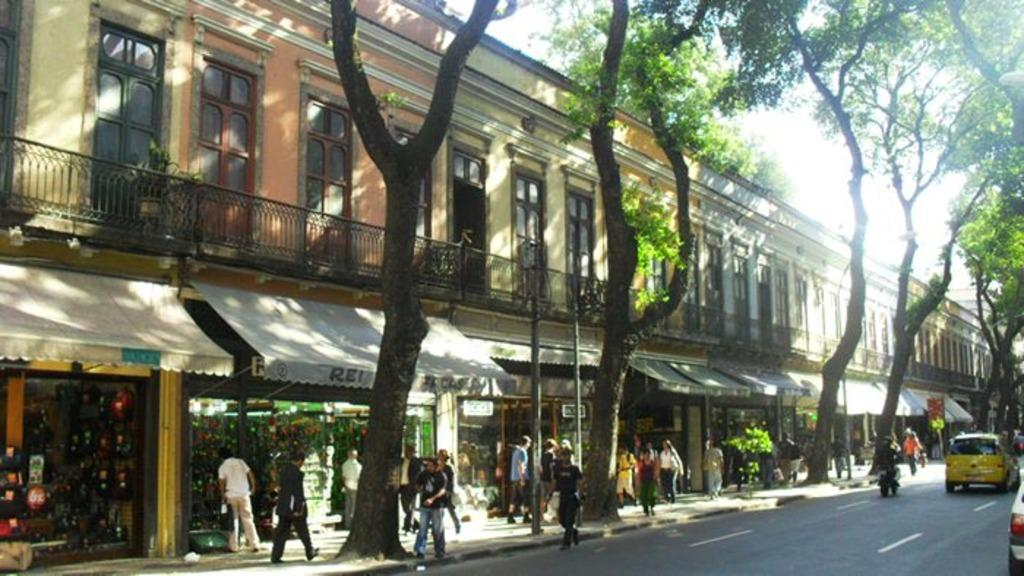What are the people in the image doing? The people in the image are walking on the road. What can be seen in the background of the image? There is a building with windows in the image, and it has stores inside. What type of vegetation is present in the image? There are trees and plants in the image. What else can be seen in the image besides people and vegetation? There are vehicles and the sky visible in the image. Can you tell me how many streams are visible in the image? There are no streams present in the image. What type of property is shown in the image? The image does not show any specific property; it features a road, a building, trees, and other elements. 